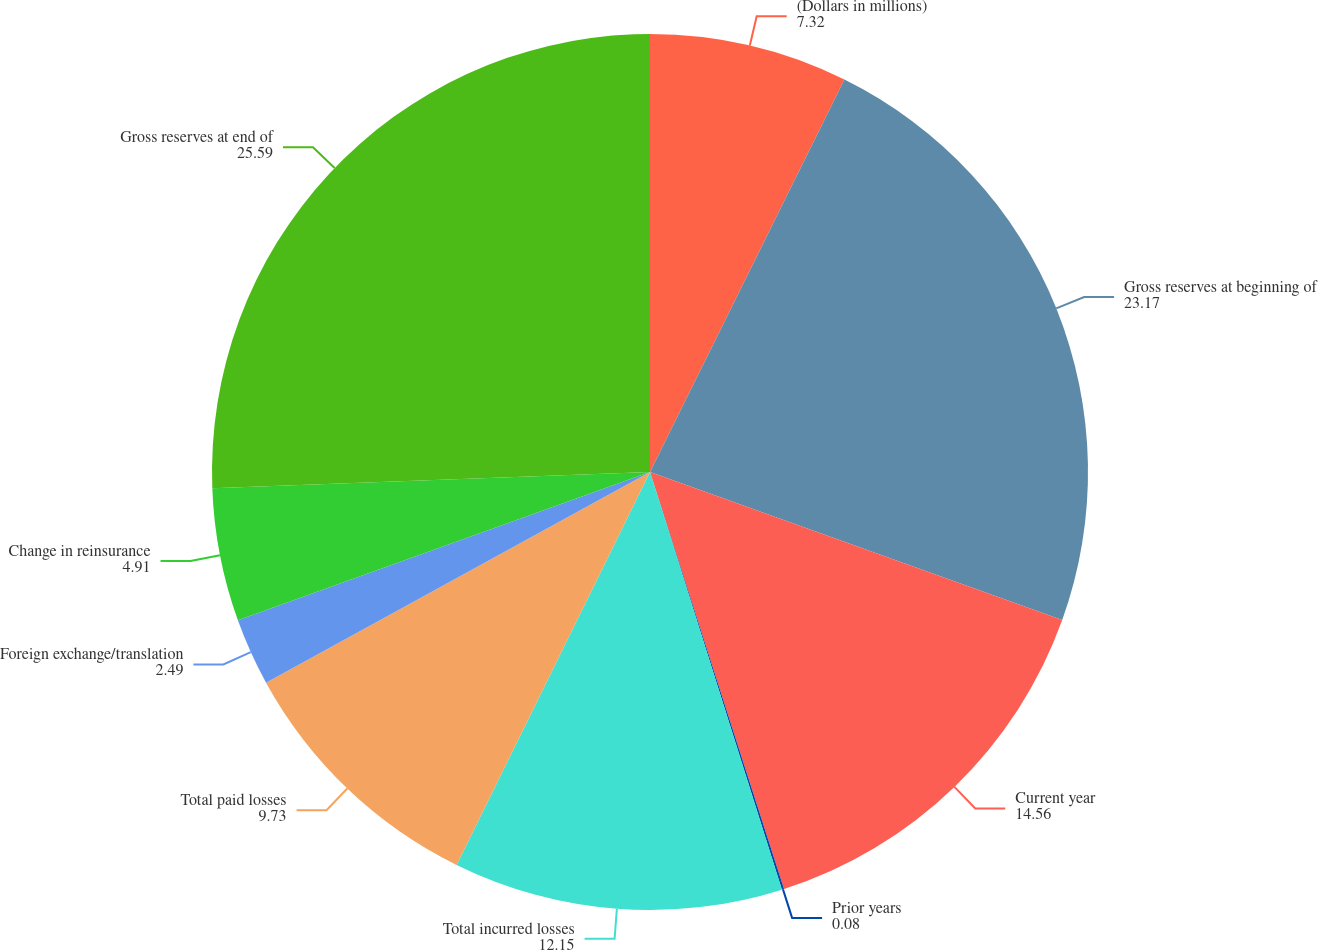<chart> <loc_0><loc_0><loc_500><loc_500><pie_chart><fcel>(Dollars in millions)<fcel>Gross reserves at beginning of<fcel>Current year<fcel>Prior years<fcel>Total incurred losses<fcel>Total paid losses<fcel>Foreign exchange/translation<fcel>Change in reinsurance<fcel>Gross reserves at end of<nl><fcel>7.32%<fcel>23.17%<fcel>14.56%<fcel>0.08%<fcel>12.15%<fcel>9.73%<fcel>2.49%<fcel>4.91%<fcel>25.59%<nl></chart> 